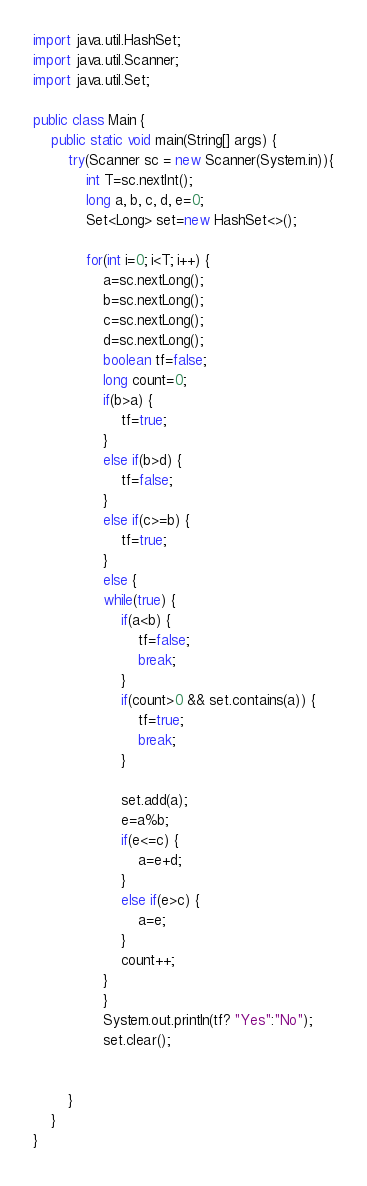Convert code to text. <code><loc_0><loc_0><loc_500><loc_500><_Java_>import java.util.HashSet;
import java.util.Scanner;
import java.util.Set;

public class Main {
	public static void main(String[] args) {
		try(Scanner sc = new Scanner(System.in)){
			int T=sc.nextInt();
			long a, b, c, d, e=0;
			Set<Long> set=new HashSet<>();
			
			for(int i=0; i<T; i++) {
				a=sc.nextLong();
				b=sc.nextLong();
				c=sc.nextLong();
				d=sc.nextLong();
				boolean tf=false;
				long count=0;
				if(b>a) {
					tf=true;
				}
				else if(b>d) {
					tf=false;
				}
				else if(c>=b) {
					tf=true;
				}
				else {
				while(true) {
					if(a<b) {
						tf=false;
						break;
					}
					if(count>0 && set.contains(a)) {
						tf=true;
						break;
					}
					
					set.add(a);
					e=a%b;
					if(e<=c) {
						a=e+d;
					}
					else if(e>c) {
						a=e;
					}
					count++;
				}
				}
				System.out.println(tf? "Yes":"No");
				set.clear();
			
			
		}
	}
}</code> 